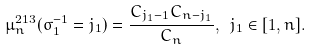Convert formula to latex. <formula><loc_0><loc_0><loc_500><loc_500>\mu _ { n } ^ { 2 1 3 } ( \sigma ^ { - 1 } _ { 1 } = j _ { 1 } ) = \frac { C _ { j _ { 1 } - 1 } C _ { n - j _ { 1 } } } { C _ { n } } , \ j _ { 1 } \in [ 1 , n ] .</formula> 